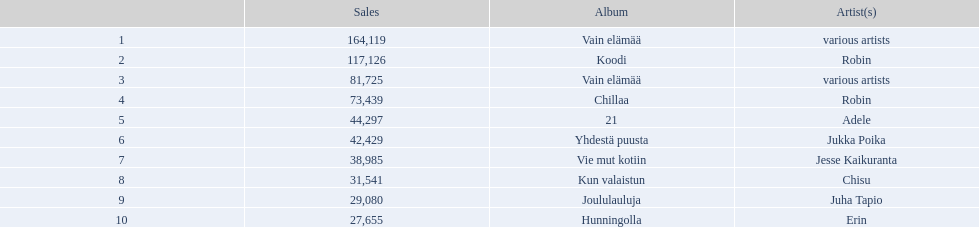Which albums had number-one albums in finland in 2012? 1, Vain elämää, Koodi, Vain elämää, Chillaa, 21, Yhdestä puusta, Vie mut kotiin, Kun valaistun, Joululauluja, Hunningolla. Of those albums, which were recorded by only one artist? Koodi, Chillaa, 21, Yhdestä puusta, Vie mut kotiin, Kun valaistun, Joululauluja, Hunningolla. Which albums made between 30,000 and 45,000 in sales? 21, Yhdestä puusta, Vie mut kotiin, Kun valaistun. Of those albums which had the highest sales? 21. Who was the artist for that album? Adele. 